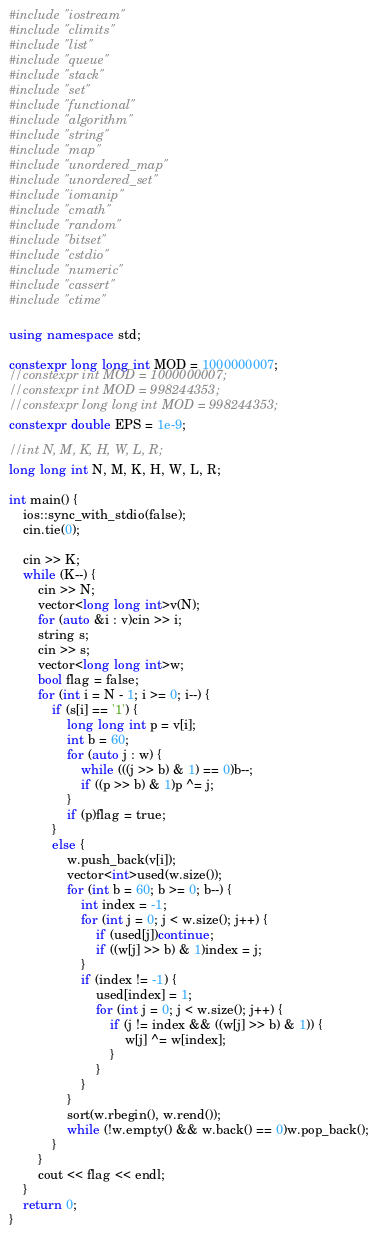<code> <loc_0><loc_0><loc_500><loc_500><_C++_>#include "iostream"
#include "climits"
#include "list"
#include "queue"
#include "stack"
#include "set"
#include "functional"
#include "algorithm"
#include "string"
#include "map"
#include "unordered_map"
#include "unordered_set"
#include "iomanip"
#include "cmath"
#include "random"
#include "bitset"
#include "cstdio"
#include "numeric"
#include "cassert"
#include "ctime"

using namespace std;

constexpr long long int MOD = 1000000007;
//constexpr int MOD = 1000000007;
//constexpr int MOD = 998244353;
//constexpr long long int MOD = 998244353;
constexpr double EPS = 1e-9;

//int N, M, K, H, W, L, R;
long long int N, M, K, H, W, L, R;

int main() {
	ios::sync_with_stdio(false);
	cin.tie(0);

	cin >> K;
	while (K--) {
		cin >> N;
		vector<long long int>v(N);
		for (auto &i : v)cin >> i;
		string s;
		cin >> s;
		vector<long long int>w;
		bool flag = false;
		for (int i = N - 1; i >= 0; i--) {
			if (s[i] == '1') {
				long long int p = v[i];
				int b = 60;
				for (auto j : w) {
					while (((j >> b) & 1) == 0)b--;
					if ((p >> b) & 1)p ^= j;
				}
				if (p)flag = true;
			}
			else {
				w.push_back(v[i]);
				vector<int>used(w.size());
				for (int b = 60; b >= 0; b--) {
					int index = -1;
					for (int j = 0; j < w.size(); j++) {
						if (used[j])continue;
						if ((w[j] >> b) & 1)index = j;
					}
					if (index != -1) {
						used[index] = 1;
						for (int j = 0; j < w.size(); j++) {
							if (j != index && ((w[j] >> b) & 1)) {
								w[j] ^= w[index];
							}
						}
					}
				}
				sort(w.rbegin(), w.rend());
				while (!w.empty() && w.back() == 0)w.pop_back(); 
			}
		}
		cout << flag << endl;
	}
	return 0;
}</code> 